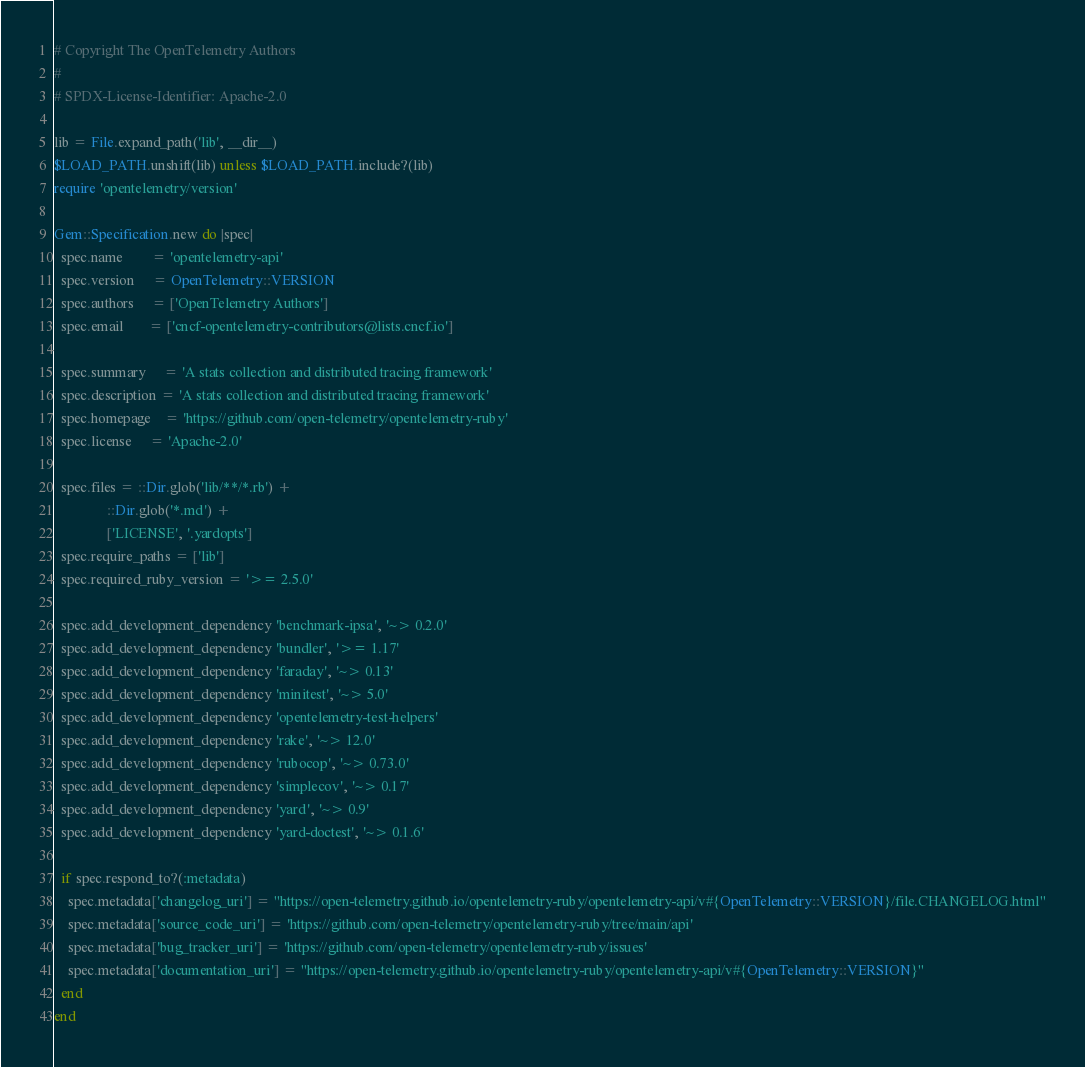Convert code to text. <code><loc_0><loc_0><loc_500><loc_500><_Ruby_>
# Copyright The OpenTelemetry Authors
#
# SPDX-License-Identifier: Apache-2.0

lib = File.expand_path('lib', __dir__)
$LOAD_PATH.unshift(lib) unless $LOAD_PATH.include?(lib)
require 'opentelemetry/version'

Gem::Specification.new do |spec|
  spec.name        = 'opentelemetry-api'
  spec.version     = OpenTelemetry::VERSION
  spec.authors     = ['OpenTelemetry Authors']
  spec.email       = ['cncf-opentelemetry-contributors@lists.cncf.io']

  spec.summary     = 'A stats collection and distributed tracing framework'
  spec.description = 'A stats collection and distributed tracing framework'
  spec.homepage    = 'https://github.com/open-telemetry/opentelemetry-ruby'
  spec.license     = 'Apache-2.0'

  spec.files = ::Dir.glob('lib/**/*.rb') +
               ::Dir.glob('*.md') +
               ['LICENSE', '.yardopts']
  spec.require_paths = ['lib']
  spec.required_ruby_version = '>= 2.5.0'

  spec.add_development_dependency 'benchmark-ipsa', '~> 0.2.0'
  spec.add_development_dependency 'bundler', '>= 1.17'
  spec.add_development_dependency 'faraday', '~> 0.13'
  spec.add_development_dependency 'minitest', '~> 5.0'
  spec.add_development_dependency 'opentelemetry-test-helpers'
  spec.add_development_dependency 'rake', '~> 12.0'
  spec.add_development_dependency 'rubocop', '~> 0.73.0'
  spec.add_development_dependency 'simplecov', '~> 0.17'
  spec.add_development_dependency 'yard', '~> 0.9'
  spec.add_development_dependency 'yard-doctest', '~> 0.1.6'

  if spec.respond_to?(:metadata)
    spec.metadata['changelog_uri'] = "https://open-telemetry.github.io/opentelemetry-ruby/opentelemetry-api/v#{OpenTelemetry::VERSION}/file.CHANGELOG.html"
    spec.metadata['source_code_uri'] = 'https://github.com/open-telemetry/opentelemetry-ruby/tree/main/api'
    spec.metadata['bug_tracker_uri'] = 'https://github.com/open-telemetry/opentelemetry-ruby/issues'
    spec.metadata['documentation_uri'] = "https://open-telemetry.github.io/opentelemetry-ruby/opentelemetry-api/v#{OpenTelemetry::VERSION}"
  end
end
</code> 